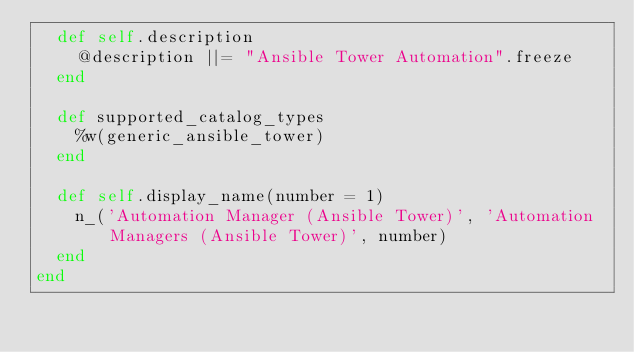Convert code to text. <code><loc_0><loc_0><loc_500><loc_500><_Ruby_>  def self.description
    @description ||= "Ansible Tower Automation".freeze
  end

  def supported_catalog_types
    %w(generic_ansible_tower)
  end

  def self.display_name(number = 1)
    n_('Automation Manager (Ansible Tower)', 'Automation Managers (Ansible Tower)', number)
  end
end
</code> 